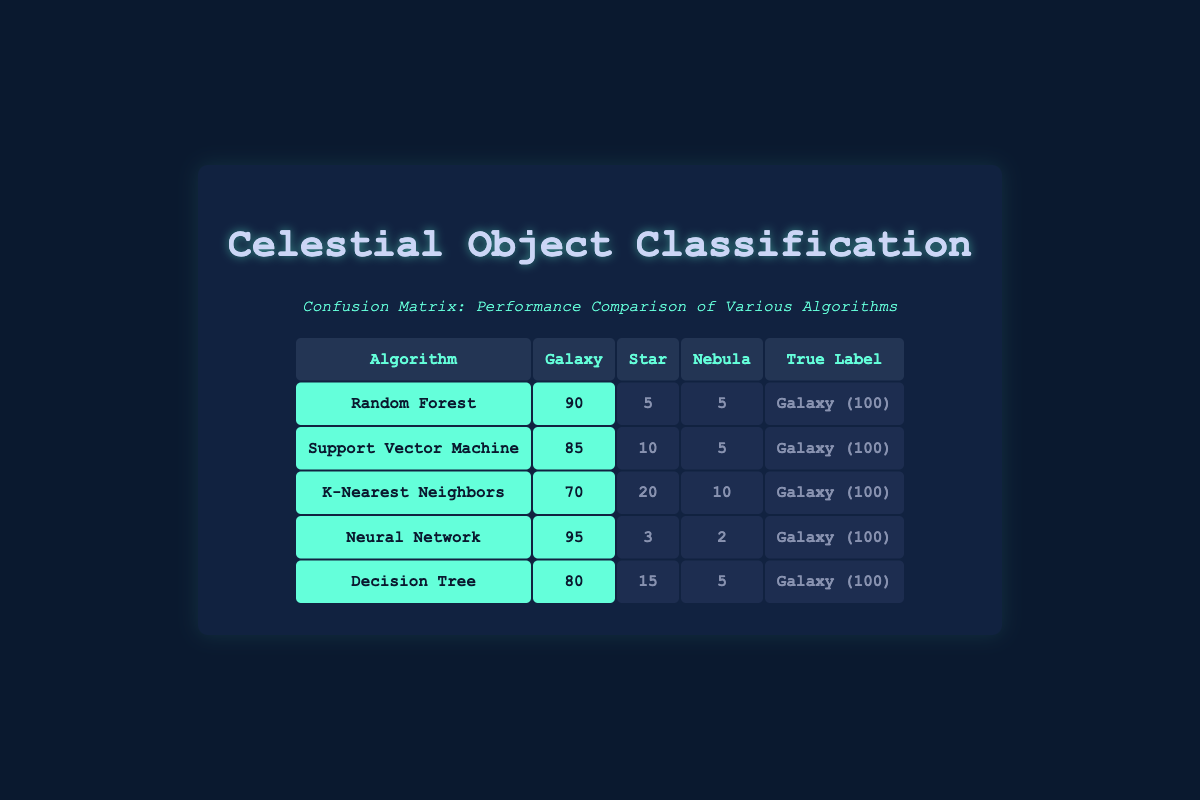What is the highest number of galaxy predictions made by an algorithm? The highest number of galaxy predictions made is found by checking the predictions in the "Galaxy" column for all algorithms. The values are 90 for Random Forest, 85 for Support Vector Machine, 70 for K-Nearest Neighbors, 95 for Neural Network, and 80 for Decision Tree. The maximum value is 95.
Answer: 95 Which algorithm misclassifies the most stars? To determine the algorithm that misclassifies the most stars, we look at the "Star" column. The values for the misclassified stars are 5 for Random Forest, 10 for Support Vector Machine, 20 for K-Nearest Neighbors, 3 for Neural Network, and 15 for Decision Tree. The maximum misclassification is 20, which occurs with K-Nearest Neighbors.
Answer: K-Nearest Neighbors What is the total number of misclassifications across all algorithms? To find the total number of misclassifications, we add the values in the "Star" and "Nebula" columns for each algorithm: (5+5) + (10+5) + (20+10) + (3+2) + (15+5) = 60. Thus, there are a total of 60 misclassifications.
Answer: 60 Is the Neural Network algorithm a better classifier for galaxies than the K-Nearest Neighbors algorithm? We can assess which algorithm is better by comparing their predicted galaxy counts. Neural Network predicts 95 galaxies, while K-Nearest Neighbors predicts 70. Since 95 is greater than 70, the Neural Network algorithm is indeed a better classifier for galaxies.
Answer: Yes What is the average number of galaxy predictions across all algorithms? To find the average predictions for galaxies, we first sum the values in the "Galaxy" column: 90 + 85 + 70 + 95 + 80 = 420. There are 5 algorithms, so the average is 420/5 = 84.
Answer: 84 Which algorithm has the lowest number of misclassified nebula predictions? The misclassified nebula predictions can be evaluated by examining the "Nebula" column: 5 for Random Forest, 5 for Support Vector Machine, 10 for K-Nearest Neighbors, 2 for Neural Network, and 5 for Decision Tree. The lowest value is 2, which corresponds to the Neural Network algorithm.
Answer: Neural Network Are there any algorithms that made zero predictions for stars? By reviewing the "Star" column across all algorithms, 0 is noted for the Support Vector Machine algorithm only. This indicates that the only algorithm that made no predictions for stars is Support Vector Machine.
Answer: Yes Which algorithm demonstrates the best classification performance based on the number of correctly predicted galaxies? To determine which algorithm demonstrates the best performance, we'll look at the highest number of correct galaxy predictions, which is represented by the "Galaxy" column. The best performance is by Neural Network with 95 correct predictions for galaxies.
Answer: Neural Network 